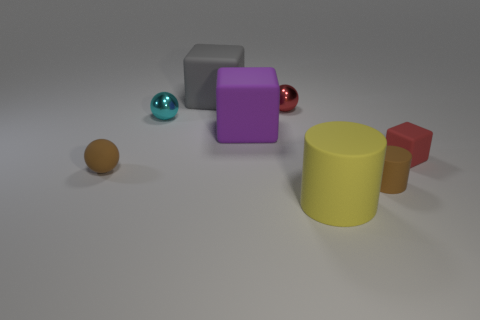What material is the red thing that is the same shape as the cyan metal thing?
Keep it short and to the point. Metal. Is the number of matte blocks that are to the left of the gray block the same as the number of large cyan objects?
Provide a succinct answer. Yes. What is the size of the cube that is both on the left side of the red matte thing and in front of the cyan metallic thing?
Keep it short and to the point. Large. Are there any other things of the same color as the small cylinder?
Give a very brief answer. Yes. There is a rubber cylinder that is in front of the brown rubber thing that is to the right of the big matte cylinder; what is its size?
Your answer should be very brief. Large. There is a rubber object that is both behind the red matte block and in front of the cyan metal sphere; what color is it?
Your answer should be very brief. Purple. How many other objects are the same size as the brown ball?
Provide a short and direct response. 4. There is a gray block; is it the same size as the brown object right of the small brown rubber sphere?
Your response must be concise. No. There is a rubber block that is the same size as the rubber sphere; what color is it?
Keep it short and to the point. Red. What size is the cyan metal ball?
Ensure brevity in your answer.  Small. 